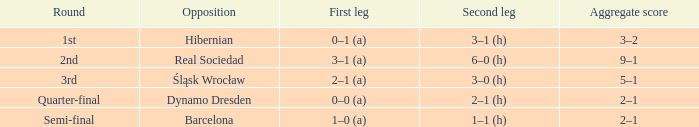What was the opening leg score against real sociedad? 3–1 (a). 